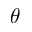Convert formula to latex. <formula><loc_0><loc_0><loc_500><loc_500>\theta</formula> 